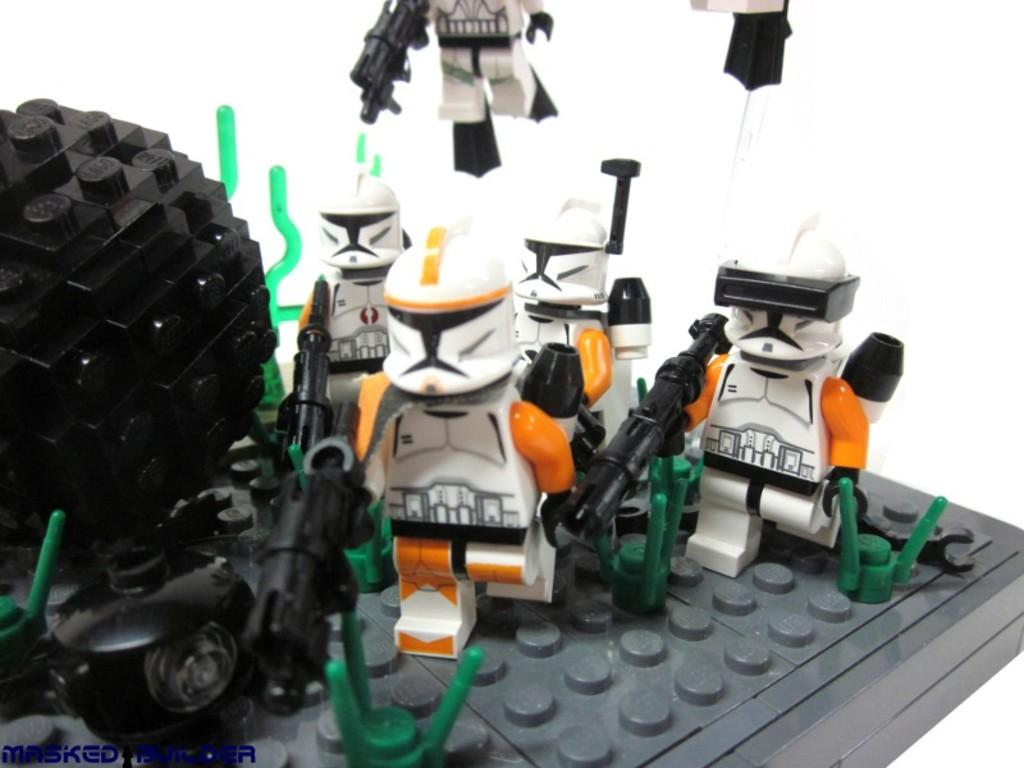What type of items can be seen in the image? There are toys in the image. What colors are the toys? The toys are in white, black, and orange colors. What is the color of the object in the image? The object is black and green in color. What is the background of the toys and object? The toys and object are on a grey color board. How does the army use the toys in the image? There is no army present in the image, and the toys are not being used for any specific purpose. 